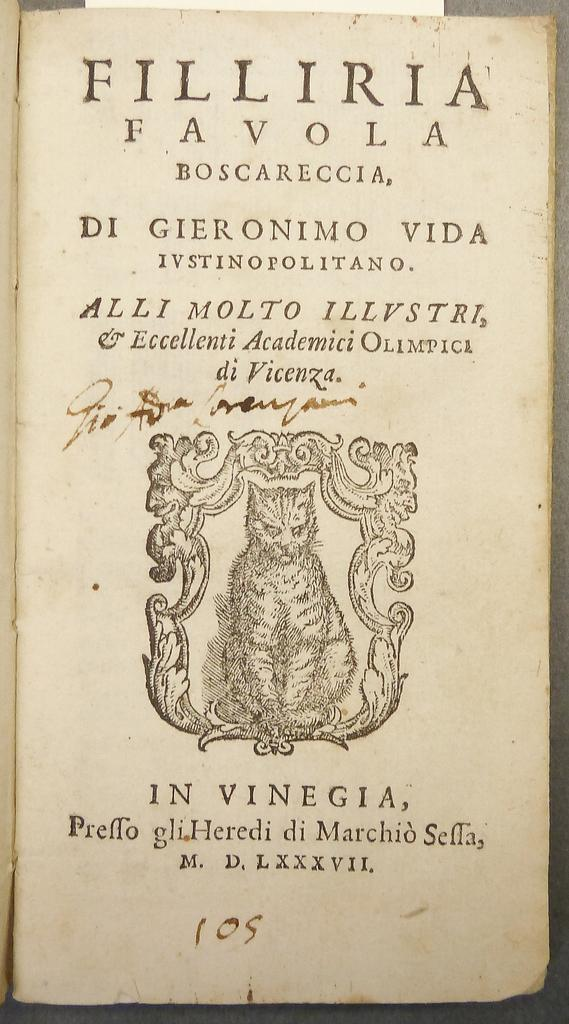<image>
Give a short and clear explanation of the subsequent image. A page from an old book with the title of Filliria Favola Boscareccia. 